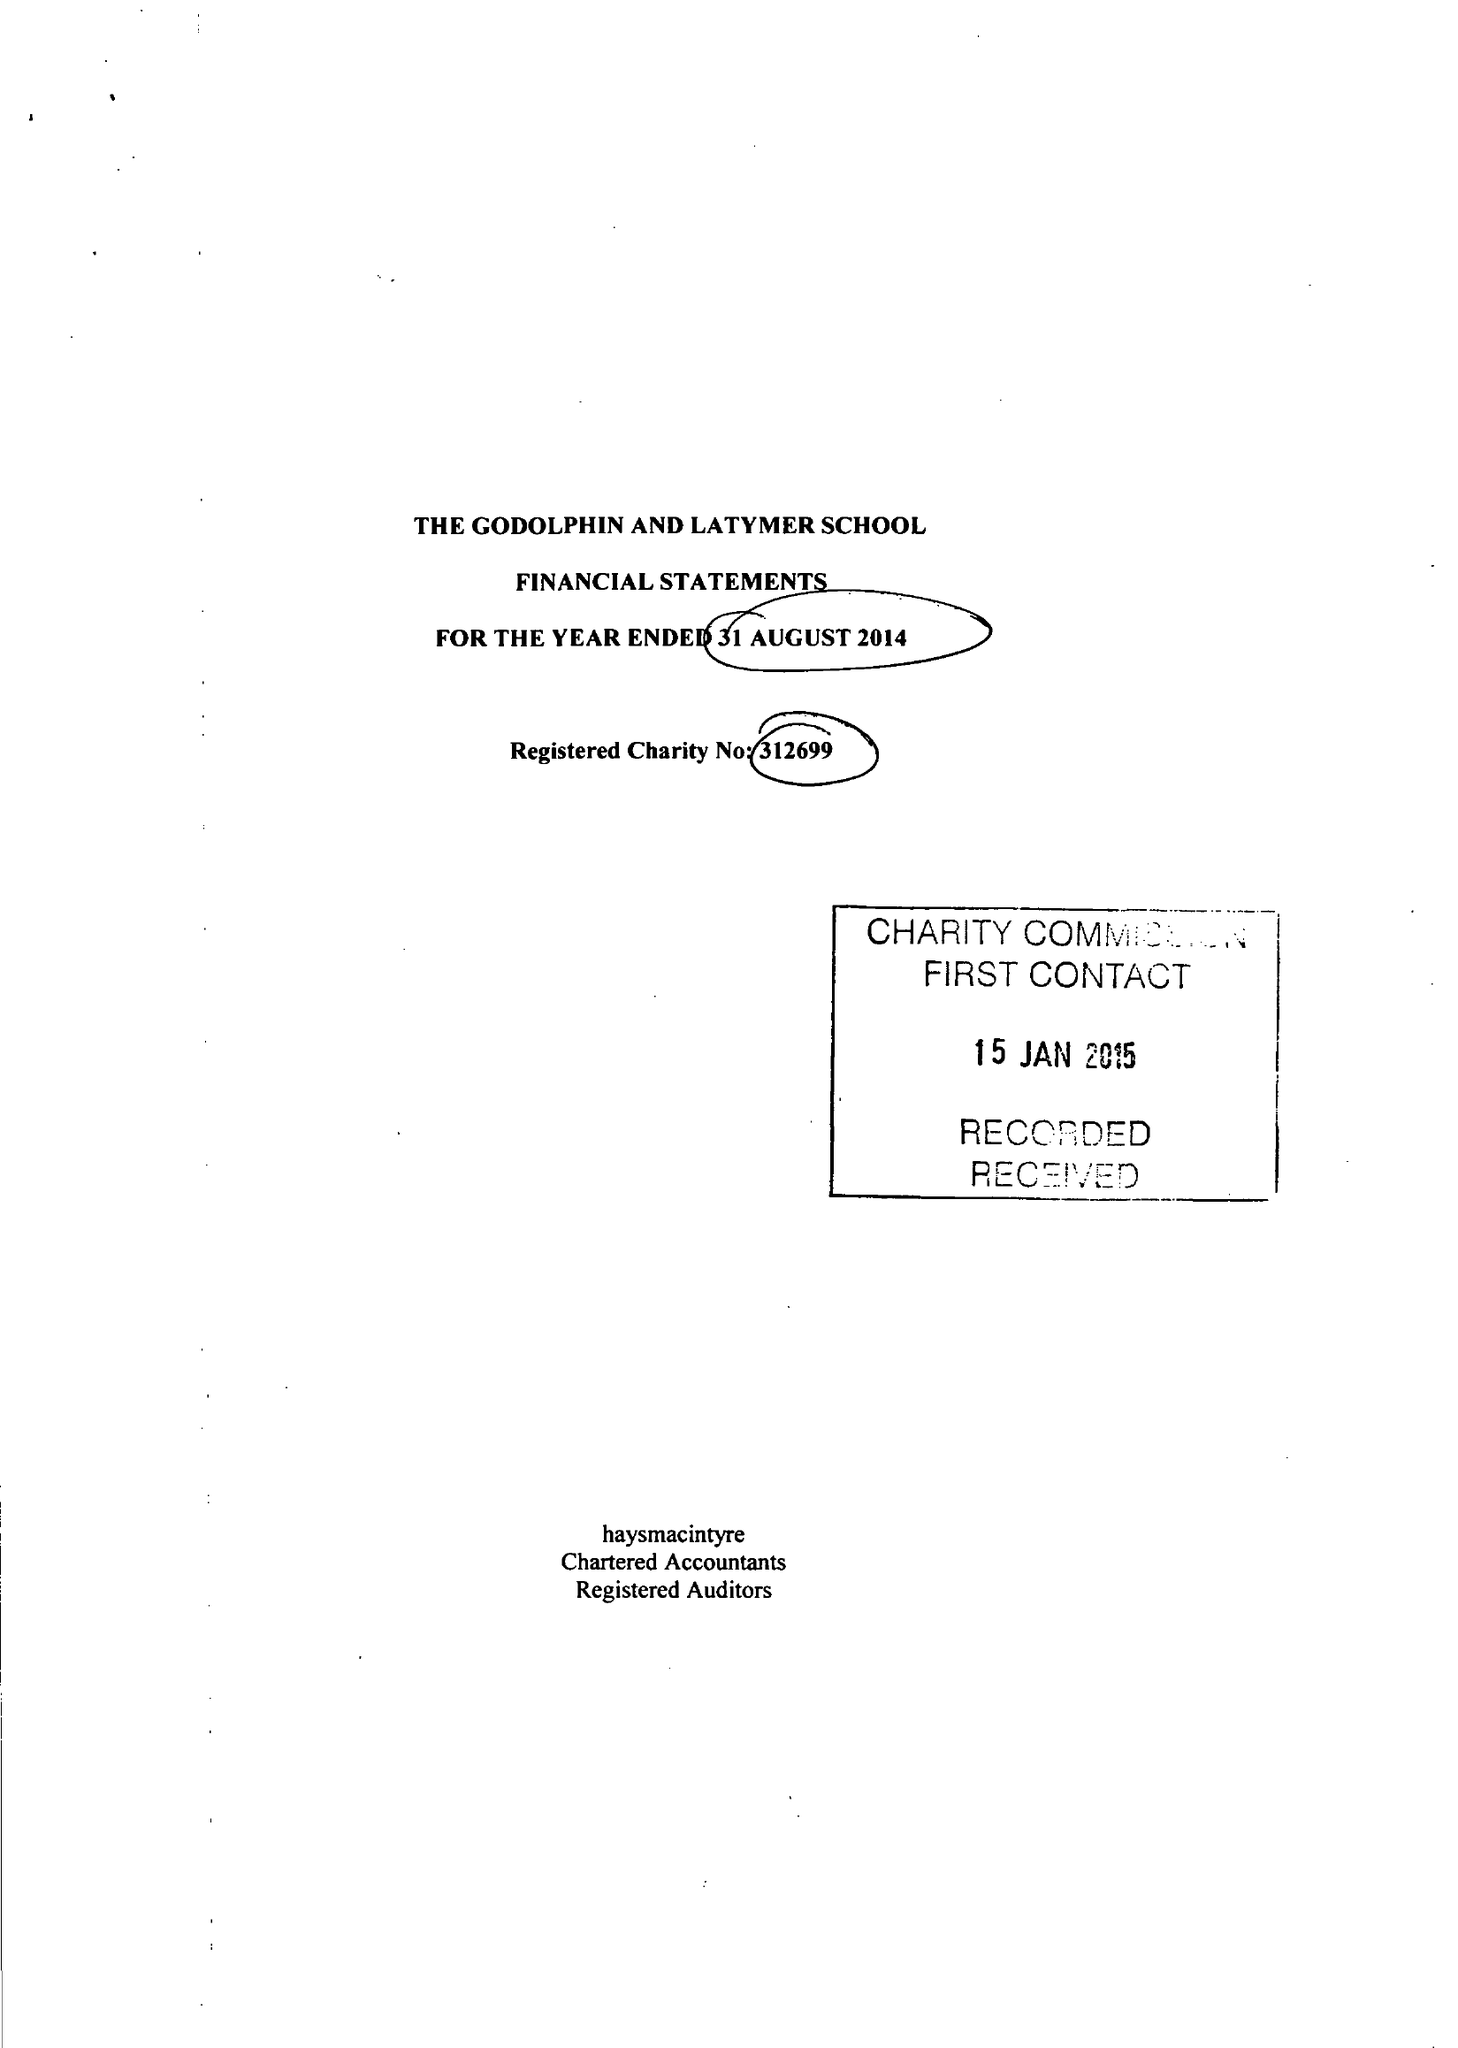What is the value for the charity_name?
Answer the question using a single word or phrase. Godolphin and Latymer School 